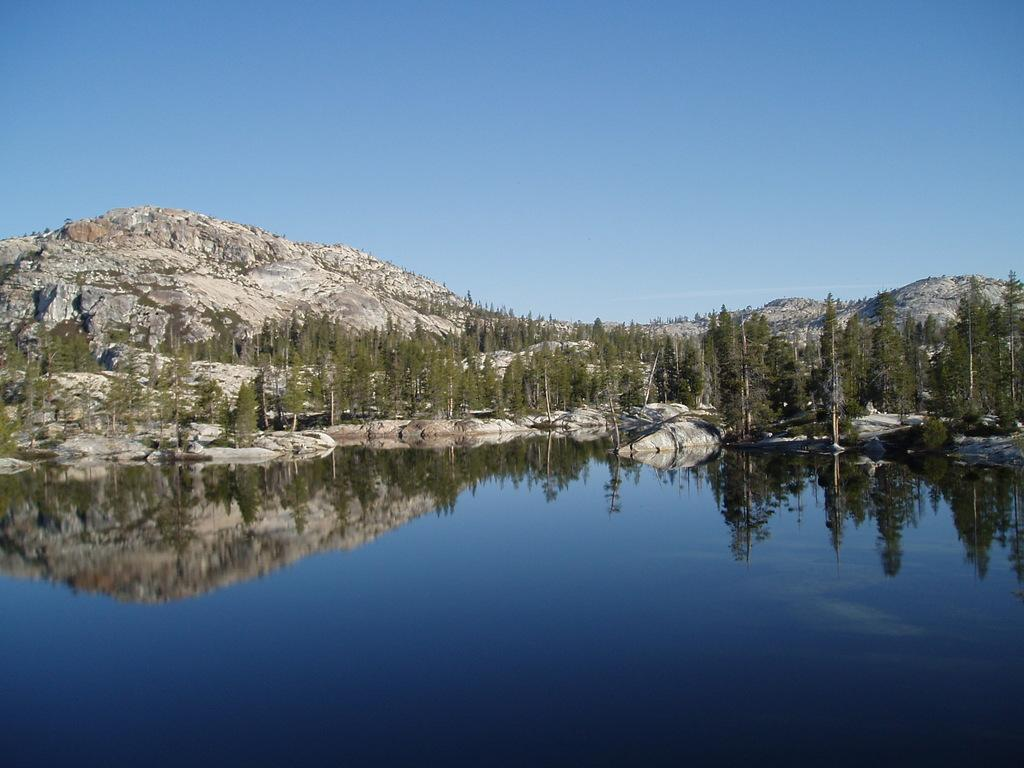What is located in front of the image? There is water in front of the image. What can be seen in the background of the image? There are trees, rocks, and mountains in the background of the image. What is visible at the top of the image? The sky is visible at the top of the image. What type of coat is hanging on the wire in the image? There is no coat or wire present in the image. What kind of fowl can be seen in the image? There is no fowl present in the image. 